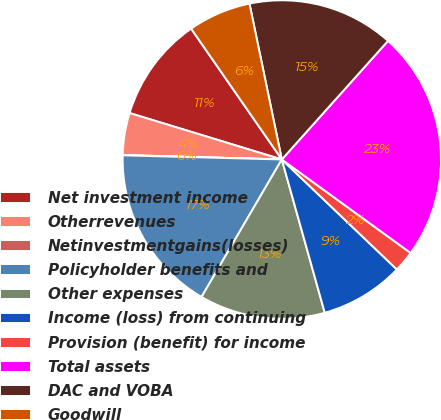Convert chart. <chart><loc_0><loc_0><loc_500><loc_500><pie_chart><fcel>Net investment income<fcel>Otherrevenues<fcel>Netinvestmentgains(losses)<fcel>Policyholder benefits and<fcel>Other expenses<fcel>Income (loss) from continuing<fcel>Provision (benefit) for income<fcel>Total assets<fcel>DAC and VOBA<fcel>Goodwill<nl><fcel>10.64%<fcel>4.27%<fcel>0.03%<fcel>17.0%<fcel>12.76%<fcel>8.51%<fcel>2.15%<fcel>23.37%<fcel>14.88%<fcel>6.39%<nl></chart> 